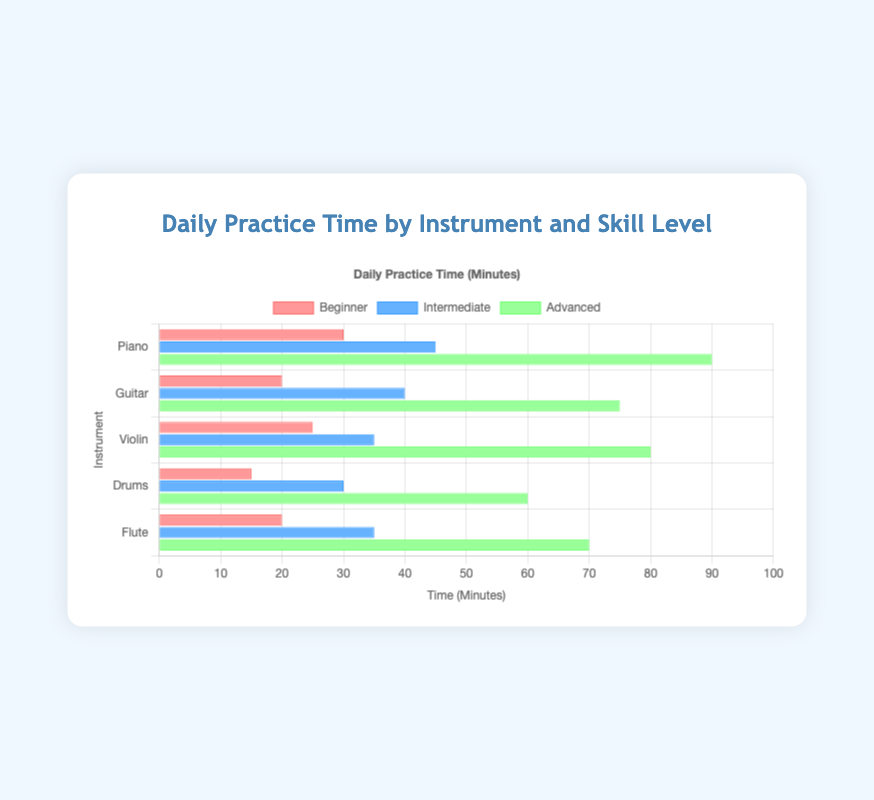What instrument do advanced players spend the most time practicing? Look at the advanced category bars for all instruments and find the one with the highest time. The advanced Piano bar is the longest.
Answer: Piano Which skill level spends more time on average practicing the Guitar: Beginner or Intermediate? Compare the bars for Beginner and Intermediate Guitar. Beginner spends 20 minutes, and Intermediate spends 40 minutes. Calculate the averages: 20/1 = 20 and 40/1 = 40.
Answer: Intermediate How much more time do advanced Drummers spend practicing daily compared to beginner Drummers? Identify the practice times for advanced Drummers (60 minutes) and beginner Drummers (15 minutes). Subtract the beginner time from the advanced time: 60 - 15 = 45 minutes.
Answer: 45 minutes Which instrument has the smallest difference in practice time between Intermediate and Advanced skill levels? Subtract Intermediate times from Advanced times for each instrument: Piano (90 - 45 = 45), Guitar (75 - 40 = 35), Violin (80 - 35 = 45), Drums (60 - 30 = 30), Flute (70 - 35 = 35). The smallest difference is for Drums.
Answer: Drums If a beginner spends time equally practicing both Guitar and Flute, what is the combined practice time? Sum the Beginner practice times for Guitar (20 minutes) and Flute (20 minutes): 20 + 20 = 40 minutes.
Answer: 40 minutes Which skill level spends the least amount of time practicing Drums? Compare the bars for Beginner, Intermediate, and Advanced Drummers. Beginner has the shortest bar with 15 minutes.
Answer: Beginner How much time will an Intermediate Violinist save compared to an Advanced Pianist if they practice together for one month (30 days)? Intermediate Violin practice time is 35 minutes, and Advanced Piano practice time is 90 minutes. Calculate the difference: 90 - 35 = 55 minutes daily. For 30 days: 55 * 30 = 1650 minutes.
Answer: 1650 minutes Is the practice time for Beginner Violin greater than the practice time for Beginner Drums? Compare bars for Beginner Violin (25 minutes) and Beginner Drums (15 minutes). The Beginner Violin time is greater.
Answer: Yes Which instrument shows the largest increase in practice time from Beginner to Advanced skill level? Calculate the differences for each instrument: Piano (90 - 30 = 60), Guitar (75 - 20 = 55), Violin (80 - 25 = 55), Drums (60 - 15 = 45), Flute (70 - 20 = 50). The largest increase is for Piano, with 60 minutes.
Answer: Piano 